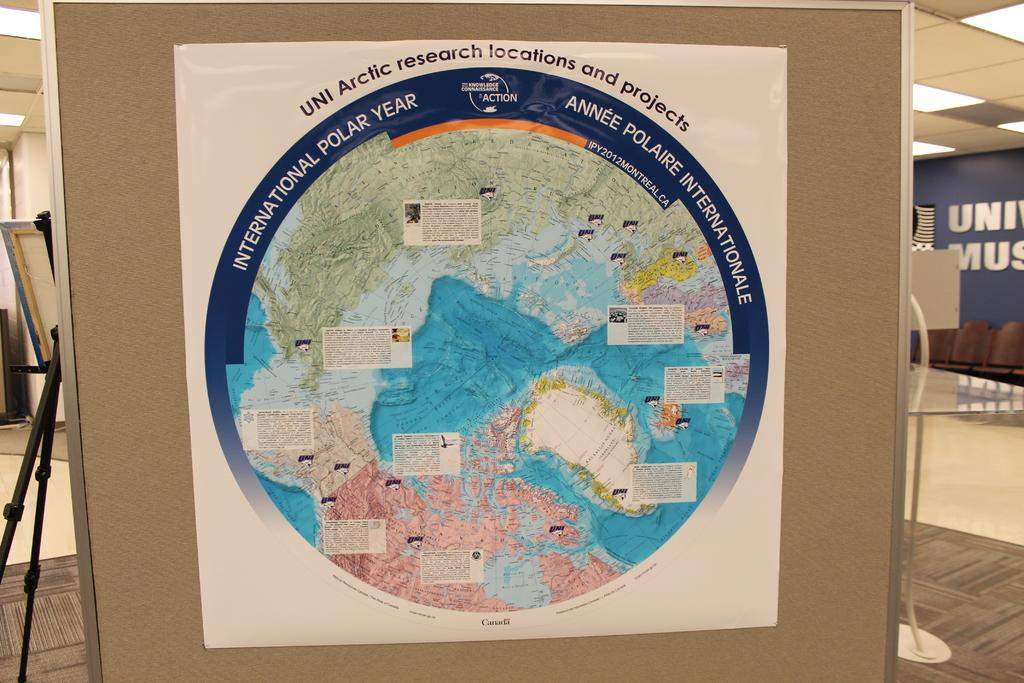What is on the board in the image? There is a poster on the board in the image. What can be seen on the floor in the background of the image? There is a stand on the floor in the background of the image. What else is visible in the background of the image? There are some objects visible in the background of the image. What time of day is it in the image, considering the presence of night? There is no mention of night or any indication of the time of day in the image. 